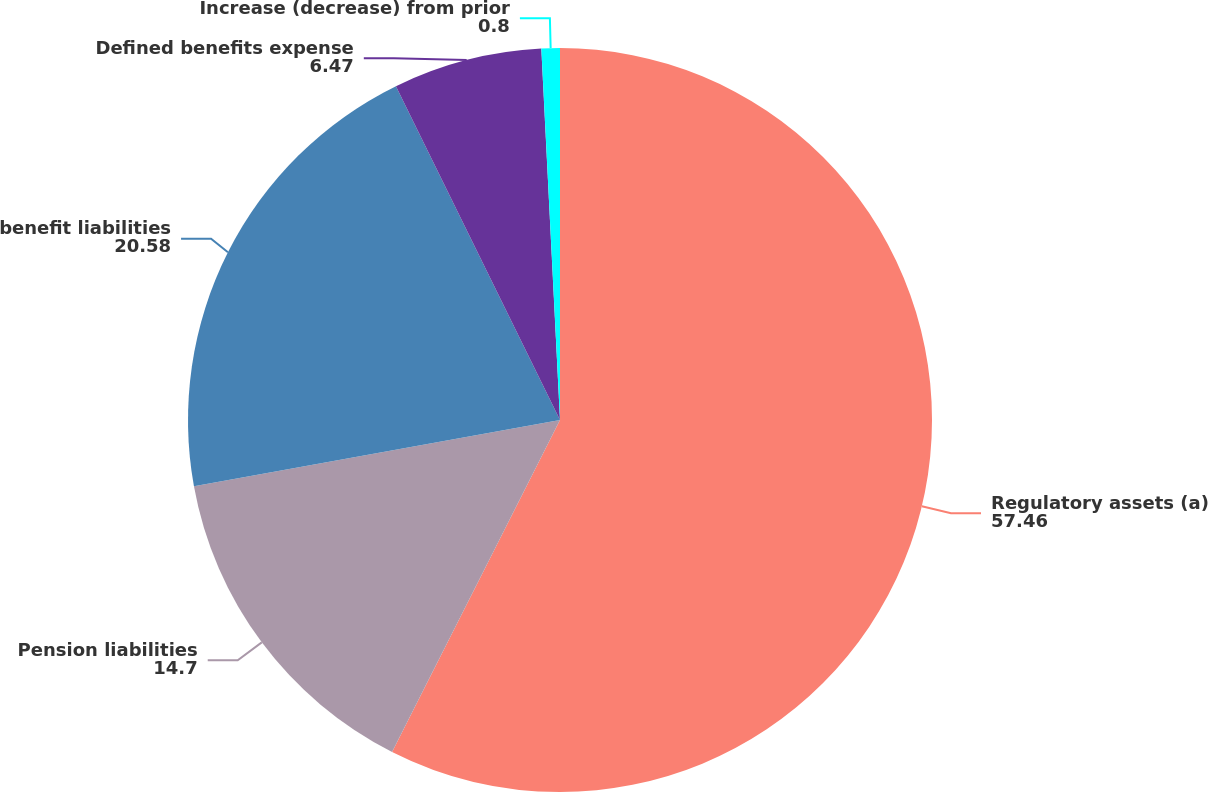Convert chart to OTSL. <chart><loc_0><loc_0><loc_500><loc_500><pie_chart><fcel>Regulatory assets (a)<fcel>Pension liabilities<fcel>benefit liabilities<fcel>Defined benefits expense<fcel>Increase (decrease) from prior<nl><fcel>57.46%<fcel>14.7%<fcel>20.58%<fcel>6.47%<fcel>0.8%<nl></chart> 